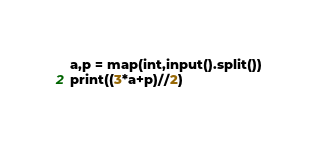Convert code to text. <code><loc_0><loc_0><loc_500><loc_500><_Python_>a,p = map(int,input().split())
print((3*a+p)//2)
</code> 